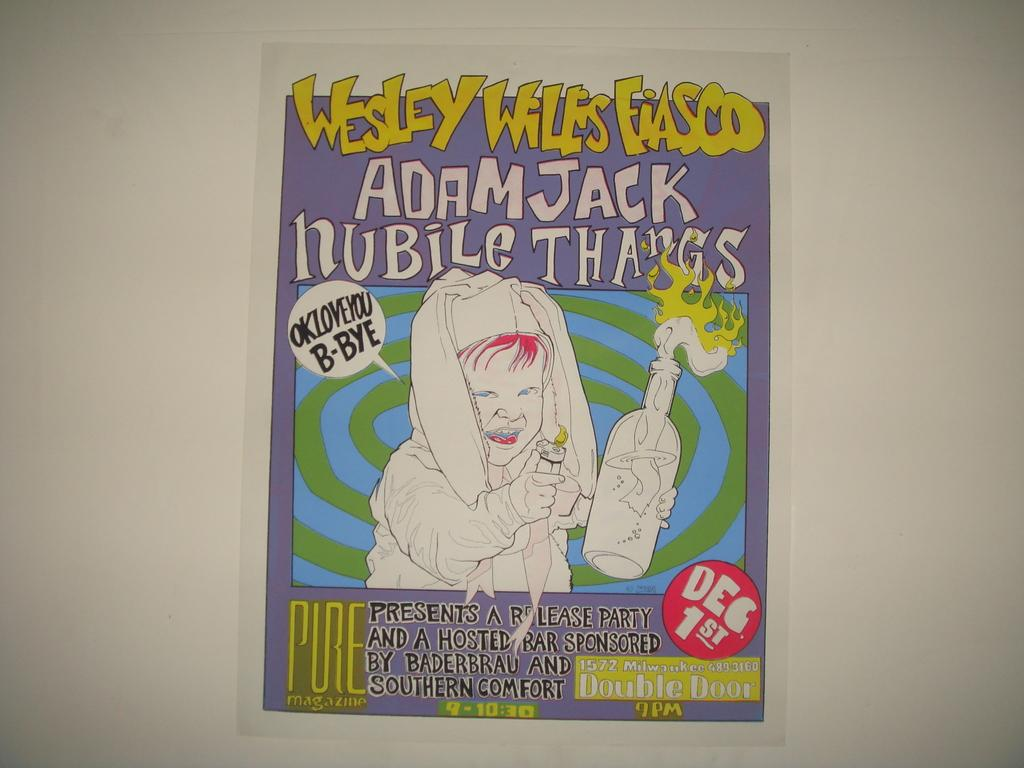<image>
Offer a succinct explanation of the picture presented. Invitation for dec. 1st for a release party, there is a bar included. 